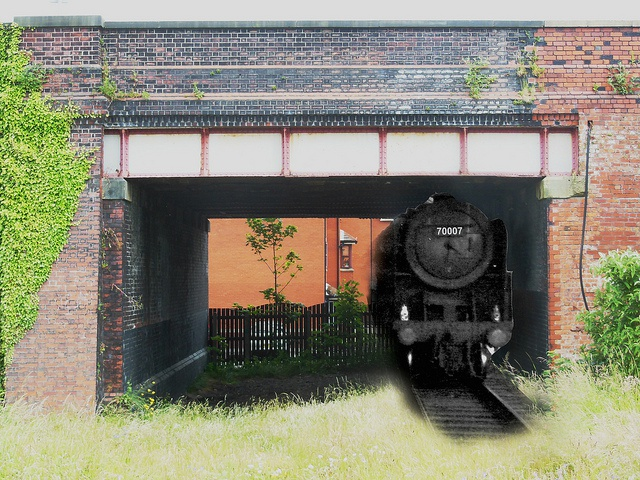Describe the objects in this image and their specific colors. I can see a train in gainsboro, black, gray, maroon, and brown tones in this image. 